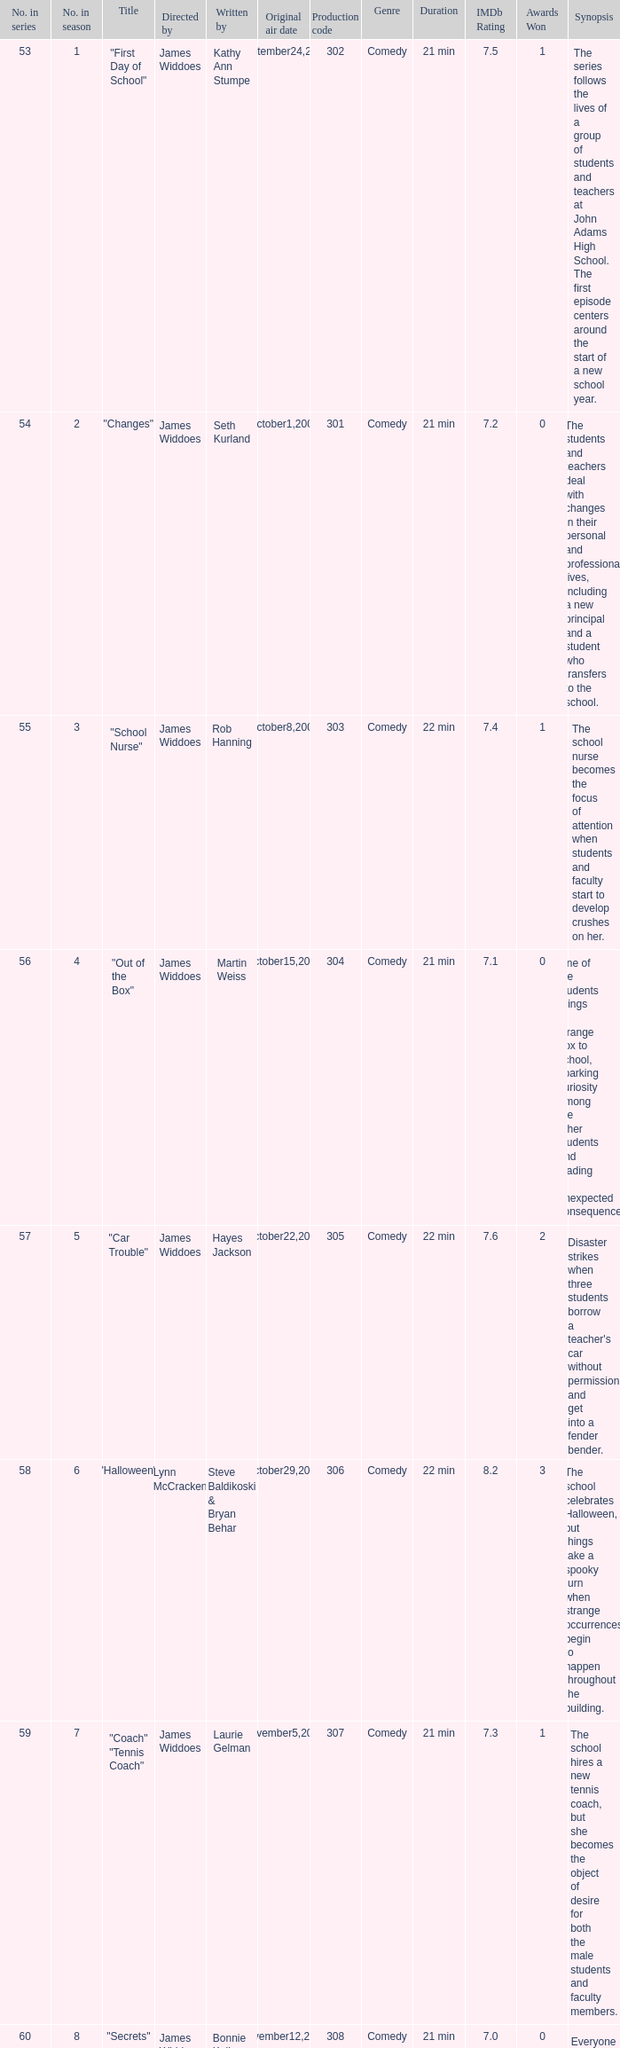What date was the episode originally aired that was directed by James Widdoes and the production code is 320? February18,2005. 